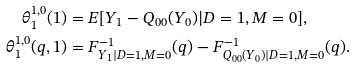Convert formula to latex. <formula><loc_0><loc_0><loc_500><loc_500>\theta _ { 1 } ^ { 1 , 0 } ( 1 ) & = E [ Y _ { 1 } - Q _ { 0 0 } ( Y _ { 0 } ) | D = 1 , M = 0 ] , \\ \theta _ { 1 } ^ { 1 , 0 } ( q , 1 ) & = F _ { Y _ { 1 } | D = 1 , M = 0 } ^ { - 1 } ( q ) - F _ { Q _ { 0 0 } ( Y _ { 0 } ) | D = 1 , M = 0 } ^ { - 1 } ( q ) .</formula> 